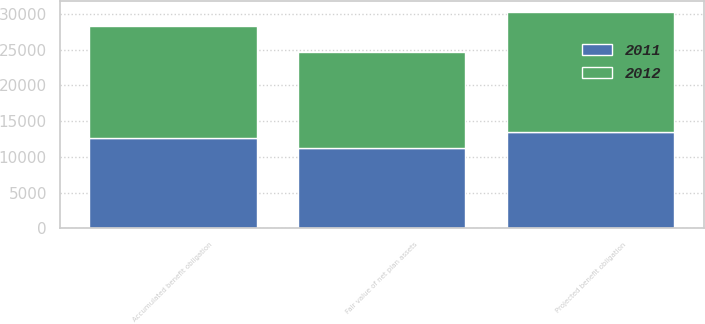Convert chart. <chart><loc_0><loc_0><loc_500><loc_500><stacked_bar_chart><ecel><fcel>Projected benefit obligation<fcel>Accumulated benefit obligation<fcel>Fair value of net plan assets<nl><fcel>2012<fcel>16796<fcel>15657<fcel>13353<nl><fcel>2011<fcel>13538<fcel>12616<fcel>11302<nl></chart> 